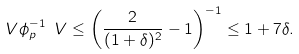<formula> <loc_0><loc_0><loc_500><loc_500>\ V \phi _ { p } ^ { - 1 } \ V \leq \left ( \frac { 2 } { ( 1 + \delta ) ^ { 2 } } - 1 \right ) ^ { - 1 } \leq 1 + 7 \delta .</formula> 